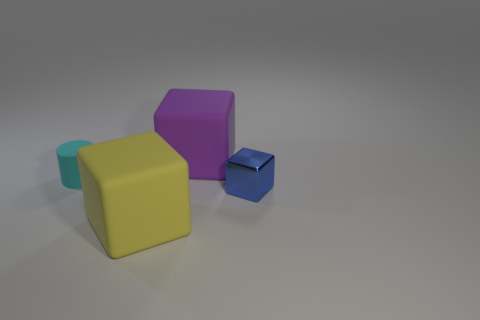There is a big matte thing behind the tiny cyan thing; is it the same shape as the blue thing?
Your response must be concise. Yes. What number of objects are cubes that are behind the small cyan matte object or rubber things right of the yellow thing?
Your answer should be compact. 1. There is a tiny thing that is the same shape as the big yellow rubber object; what is its color?
Provide a short and direct response. Blue. Is there anything else that is the same shape as the big purple thing?
Provide a succinct answer. Yes. Do the large yellow rubber thing and the tiny thing behind the blue block have the same shape?
Your response must be concise. No. What material is the small cylinder?
Make the answer very short. Rubber. There is a purple thing that is the same shape as the tiny blue shiny object; what is its size?
Your answer should be compact. Large. What number of other things are the same material as the small cylinder?
Provide a short and direct response. 2. Is the tiny cyan thing made of the same material as the small object on the right side of the large purple matte block?
Ensure brevity in your answer.  No. Is the number of cubes that are left of the yellow rubber thing less than the number of large rubber blocks behind the cyan thing?
Your answer should be compact. Yes. 